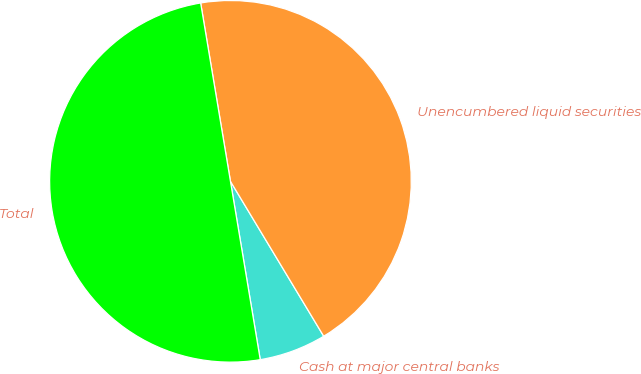<chart> <loc_0><loc_0><loc_500><loc_500><pie_chart><fcel>Cash at major central banks<fcel>Unencumbered liquid securities<fcel>Total<nl><fcel>5.99%<fcel>44.01%<fcel>50.0%<nl></chart> 